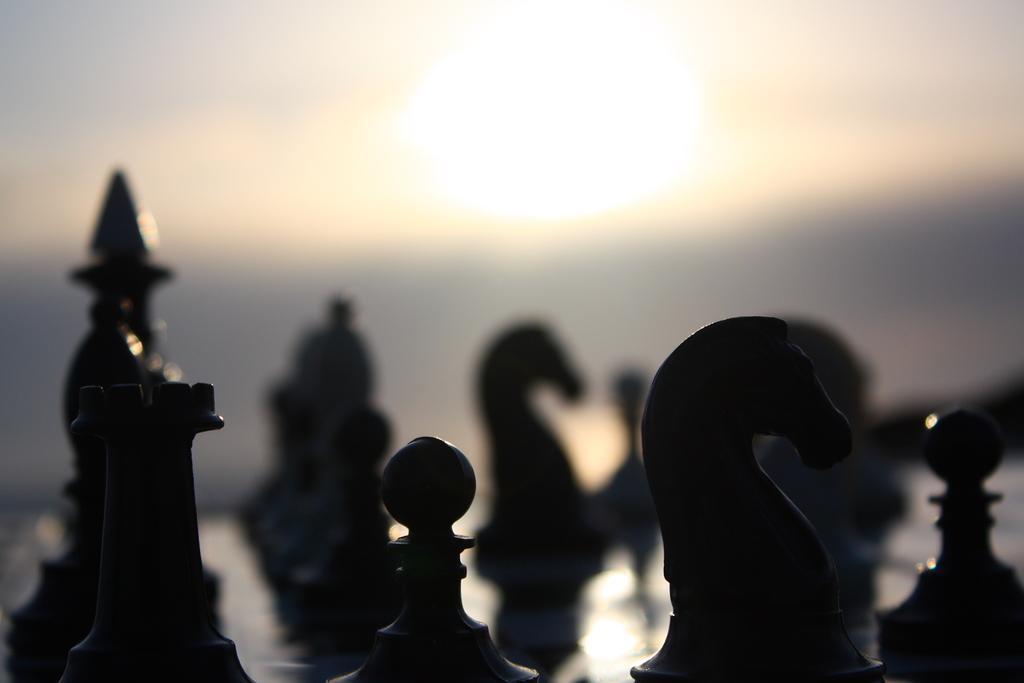In one or two sentences, can you explain what this image depicts? In this image we can see chess board. 